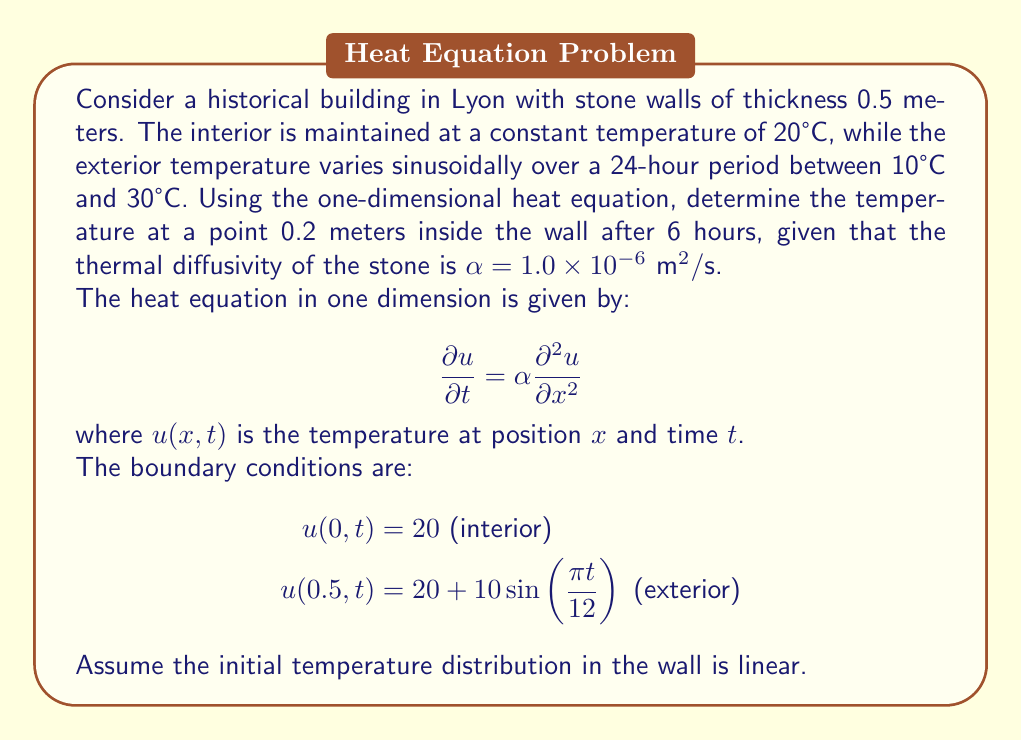Can you solve this math problem? To solve this problem, we'll use the separation of variables method for the heat equation.

1) First, let's separate the solution into steady-state and transient parts:
   $u(x,t) = v(x) + w(x,t)$

2) The steady-state solution $v(x)$ satisfies:
   $\frac{d^2v}{dx^2} = 0$
   $v(0) = 20$, $v(0.5) = 20$
   
   This gives us: $v(x) = 20$

3) For the transient part $w(x,t)$, we have:
   $\frac{\partial w}{\partial t} = \alpha \frac{\partial^2 w}{\partial x^2}$
   $w(0,t) = 0$, $w(0.5,t) = 10\sin(\frac{\pi t}{12})$

4) We can express $w(x,t)$ as:
   $w(x,t) = X(x)T(t)$

5) Substituting this into the heat equation:
   $X(x)T'(t) = \alpha X''(x)T(t)$
   
   $\frac{T'(t)}{\alpha T(t)} = \frac{X''(x)}{X(x)} = -\lambda^2$

6) This gives us two equations:
   $T'(t) + \alpha\lambda^2 T(t) = 0$
   $X''(x) + \lambda^2 X(x) = 0$

7) Solving these with the boundary conditions:
   $X(x) = A\sin(\lambda x)$
   $T(t) = Be^{-\alpha\lambda^2 t}$

8) The general solution is:
   $w(x,t) = \sum_{n=1}^{\infty} A_n \sin(\lambda_n x)e^{-\alpha\lambda_n^2 t}$

   where $\lambda_n = \frac{n\pi}{L}$ and $L = 0.5$ meters

9) To match the boundary condition at $x=0.5$:
   $10\sin(\frac{\pi t}{12}) = \sum_{n=1}^{\infty} A_n \sin(n\pi)e^{-\alpha(n\pi/0.5)^2 t}$

10) This is satisfied when:
    $A_n = \frac{20}{n\pi}$ for odd $n$, and $A_n = 0$ for even $n$

11) Therefore, the complete solution is:
    $u(x,t) = 20 + \sum_{n=1,3,5,...}^{\infty} \frac{20}{n\pi} \sin(\frac{n\pi x}{0.5})e^{-\alpha(n\pi/0.5)^2 t}$

12) To find the temperature at $x=0.2$ meters after 6 hours:
    $t = 6 \times 3600 = 21600$ seconds
    $x = 0.2$ meters

13) Substituting these values and calculating the first few terms of the series:
    $u(0.2, 21600) \approx 20 + 12.73 \sin(1.26\pi) - 4.24 \sin(3.77\pi) + 2.55 \sin(6.28\pi) - ...$

14) Evaluating this numerically:
    $u(0.2, 21600) \approx 22.8°C$
Answer: The temperature at a point 0.2 meters inside the wall after 6 hours is approximately 22.8°C. 